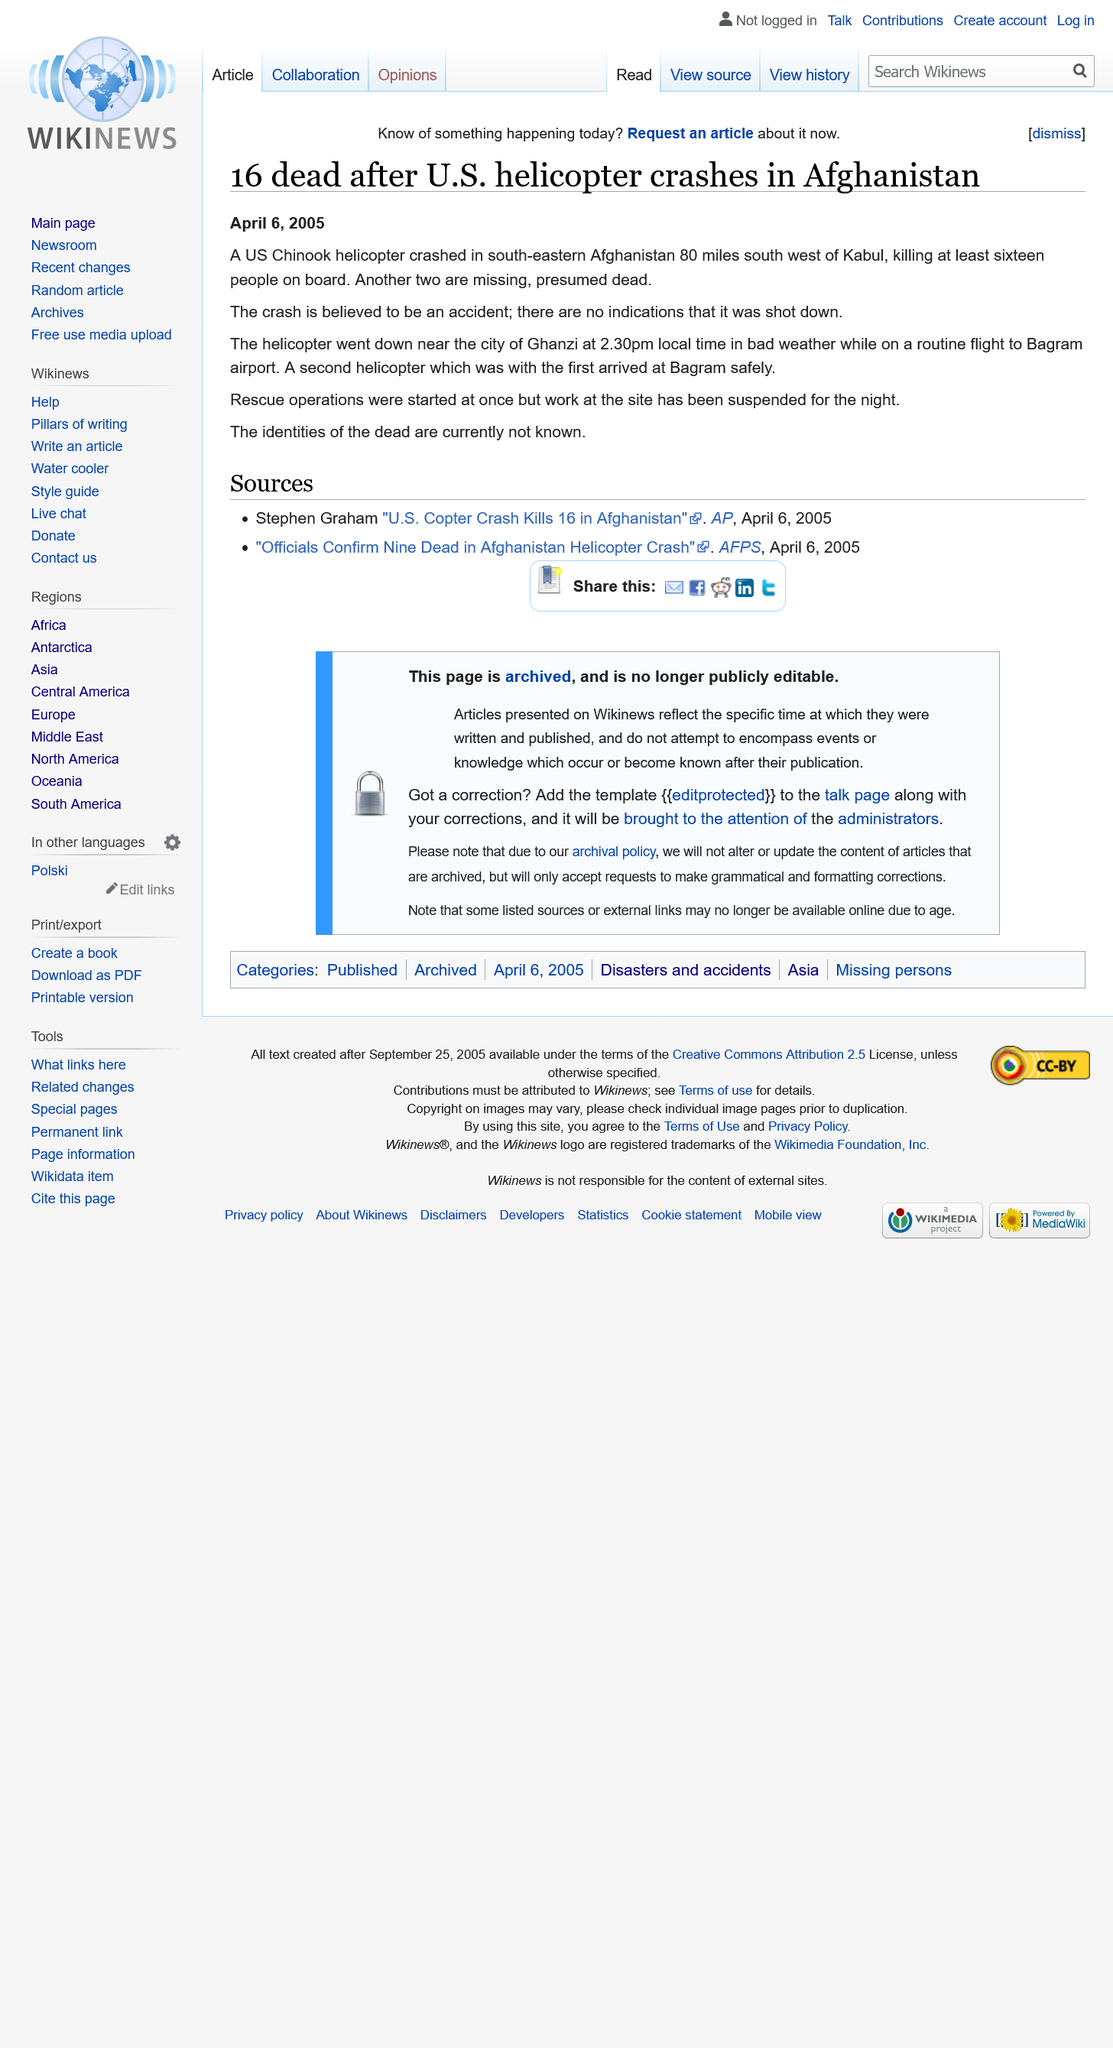Indicate a few pertinent items in this graphic. The crash occurred in south-eastern Afghanistan, approximately 80 miles south of Kabul. A total of 16 people lost their lives in the helicopter crash, and an additional 2 individuals are missing, presumed dead. The helicopter crashed at 2:30 PM local time. 